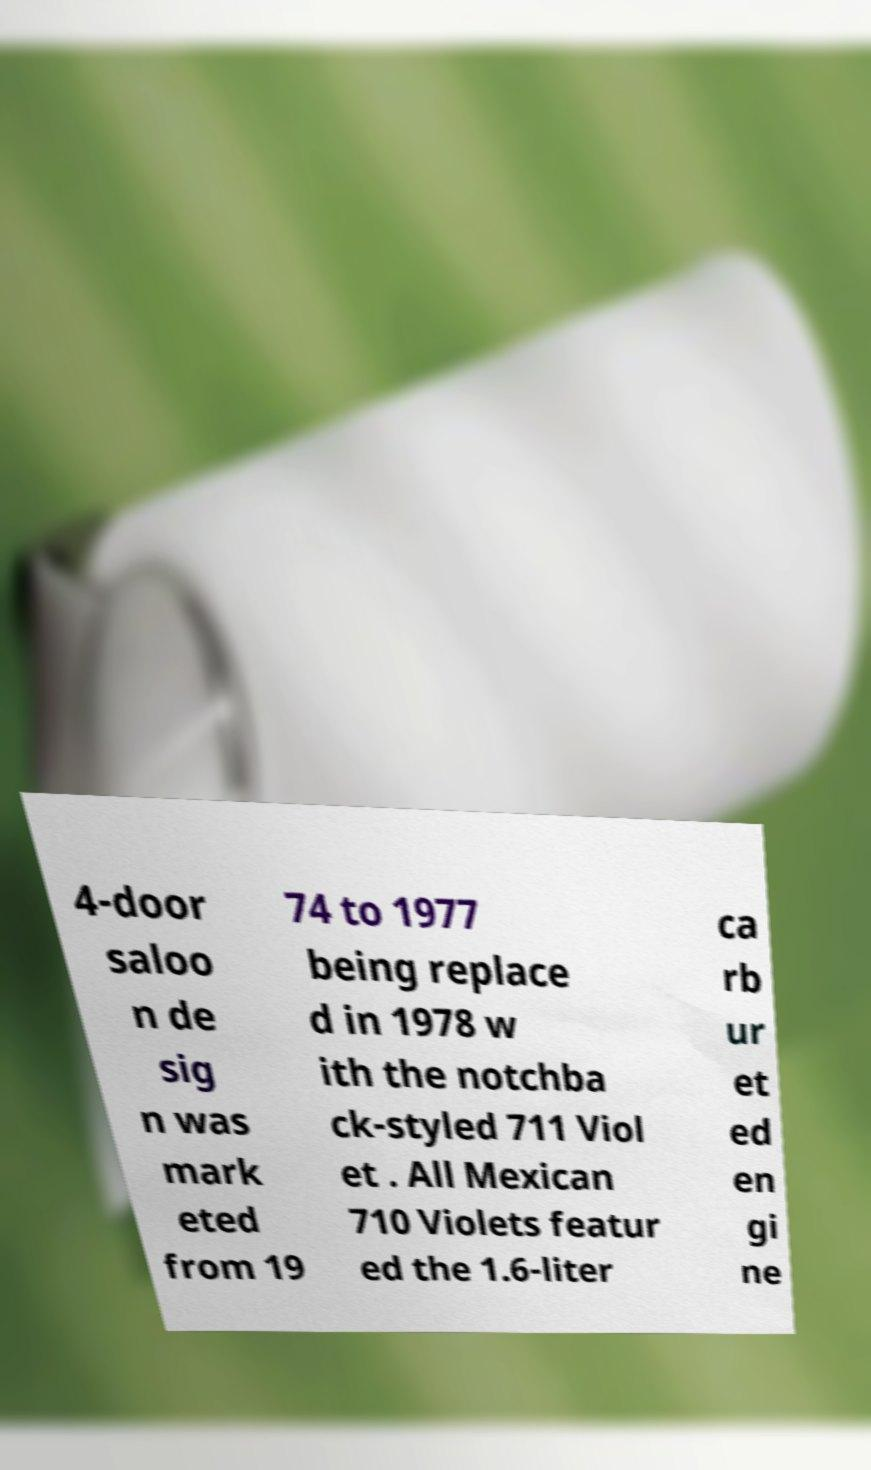I need the written content from this picture converted into text. Can you do that? 4-door saloo n de sig n was mark eted from 19 74 to 1977 being replace d in 1978 w ith the notchba ck-styled 711 Viol et . All Mexican 710 Violets featur ed the 1.6-liter ca rb ur et ed en gi ne 